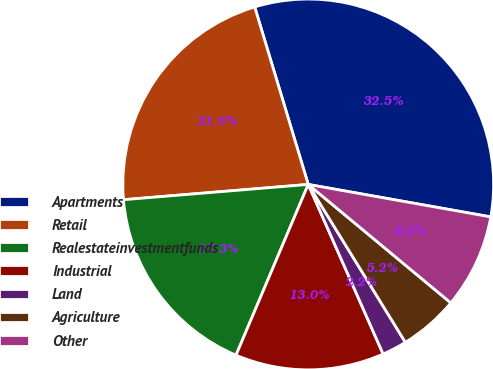Convert chart. <chart><loc_0><loc_0><loc_500><loc_500><pie_chart><fcel>Apartments<fcel>Retail<fcel>Realestateinvestmentfunds<fcel>Industrial<fcel>Land<fcel>Agriculture<fcel>Other<nl><fcel>32.47%<fcel>21.65%<fcel>17.32%<fcel>12.99%<fcel>2.16%<fcel>5.19%<fcel>8.23%<nl></chart> 